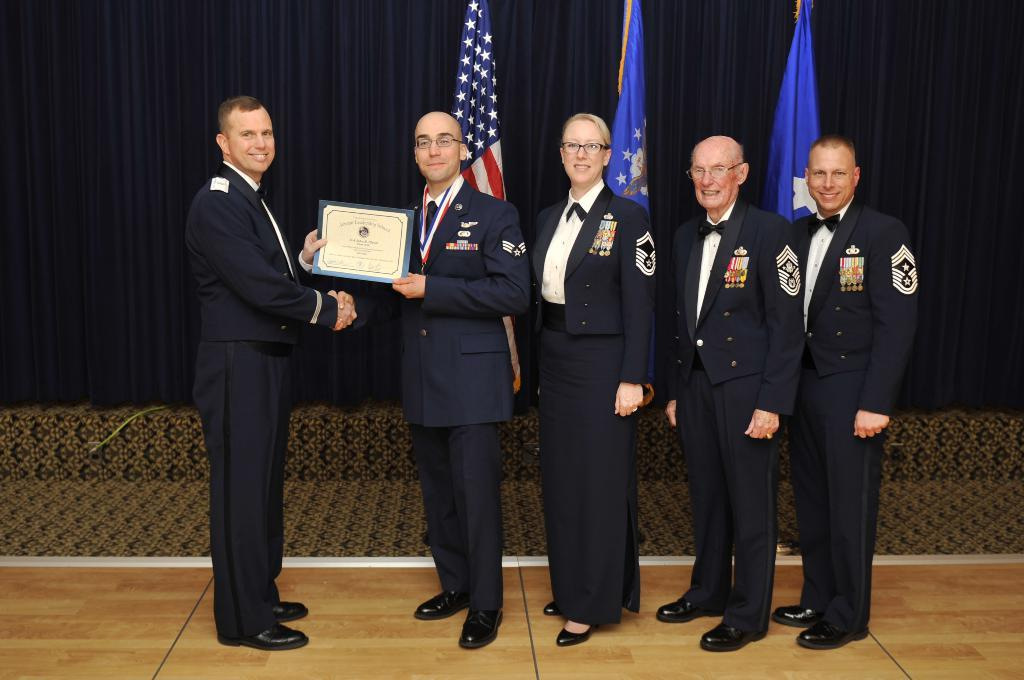How many people are in the image? There are people in the image, but the exact number is not specified. What is the facial expression of the people in the image? The people in the image are smiling. What is the person holding in the image? One person is holding a memo. What is the person holding the memo doing? The person holding the memo is giving it to another person. What can be seen in the background of the image? Flags are visible in the image. What type of root can be seen growing from the ground in the image? There is no mention of a root or ground in the image; it features people, a memo, and flags. 